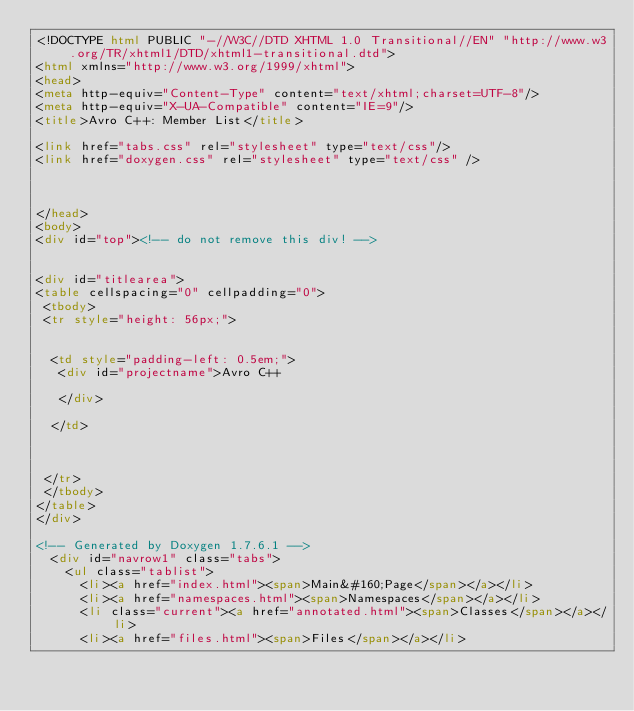<code> <loc_0><loc_0><loc_500><loc_500><_HTML_><!DOCTYPE html PUBLIC "-//W3C//DTD XHTML 1.0 Transitional//EN" "http://www.w3.org/TR/xhtml1/DTD/xhtml1-transitional.dtd">
<html xmlns="http://www.w3.org/1999/xhtml">
<head>
<meta http-equiv="Content-Type" content="text/xhtml;charset=UTF-8"/>
<meta http-equiv="X-UA-Compatible" content="IE=9"/>
<title>Avro C++: Member List</title>

<link href="tabs.css" rel="stylesheet" type="text/css"/>
<link href="doxygen.css" rel="stylesheet" type="text/css" />



</head>
<body>
<div id="top"><!-- do not remove this div! -->


<div id="titlearea">
<table cellspacing="0" cellpadding="0">
 <tbody>
 <tr style="height: 56px;">
  
  
  <td style="padding-left: 0.5em;">
   <div id="projectname">Avro C++
   
   </div>
   
  </td>
  
  
  
 </tr>
 </tbody>
</table>
</div>

<!-- Generated by Doxygen 1.7.6.1 -->
  <div id="navrow1" class="tabs">
    <ul class="tablist">
      <li><a href="index.html"><span>Main&#160;Page</span></a></li>
      <li><a href="namespaces.html"><span>Namespaces</span></a></li>
      <li class="current"><a href="annotated.html"><span>Classes</span></a></li>
      <li><a href="files.html"><span>Files</span></a></li></code> 